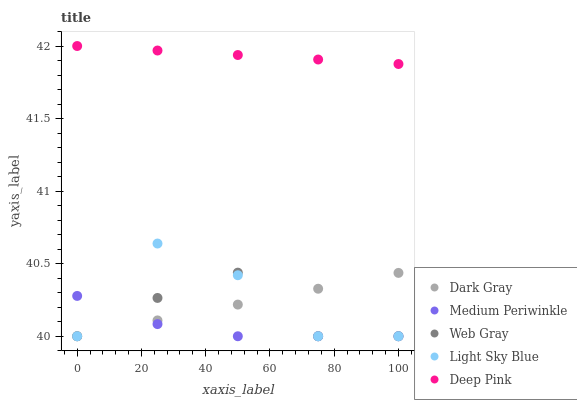Does Medium Periwinkle have the minimum area under the curve?
Answer yes or no. Yes. Does Deep Pink have the maximum area under the curve?
Answer yes or no. Yes. Does Web Gray have the minimum area under the curve?
Answer yes or no. No. Does Web Gray have the maximum area under the curve?
Answer yes or no. No. Is Dark Gray the smoothest?
Answer yes or no. Yes. Is Light Sky Blue the roughest?
Answer yes or no. Yes. Is Web Gray the smoothest?
Answer yes or no. No. Is Web Gray the roughest?
Answer yes or no. No. Does Dark Gray have the lowest value?
Answer yes or no. Yes. Does Deep Pink have the lowest value?
Answer yes or no. No. Does Deep Pink have the highest value?
Answer yes or no. Yes. Does Web Gray have the highest value?
Answer yes or no. No. Is Light Sky Blue less than Deep Pink?
Answer yes or no. Yes. Is Deep Pink greater than Web Gray?
Answer yes or no. Yes. Does Medium Periwinkle intersect Web Gray?
Answer yes or no. Yes. Is Medium Periwinkle less than Web Gray?
Answer yes or no. No. Is Medium Periwinkle greater than Web Gray?
Answer yes or no. No. Does Light Sky Blue intersect Deep Pink?
Answer yes or no. No. 